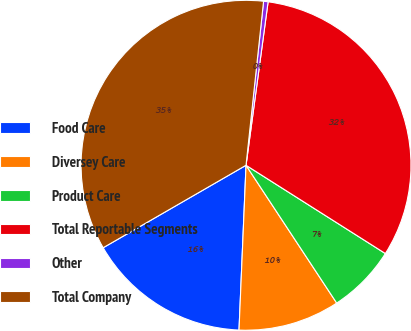Convert chart to OTSL. <chart><loc_0><loc_0><loc_500><loc_500><pie_chart><fcel>Food Care<fcel>Diversey Care<fcel>Product Care<fcel>Total Reportable Segments<fcel>Other<fcel>Total Company<nl><fcel>15.99%<fcel>9.94%<fcel>6.75%<fcel>31.85%<fcel>0.44%<fcel>35.03%<nl></chart> 